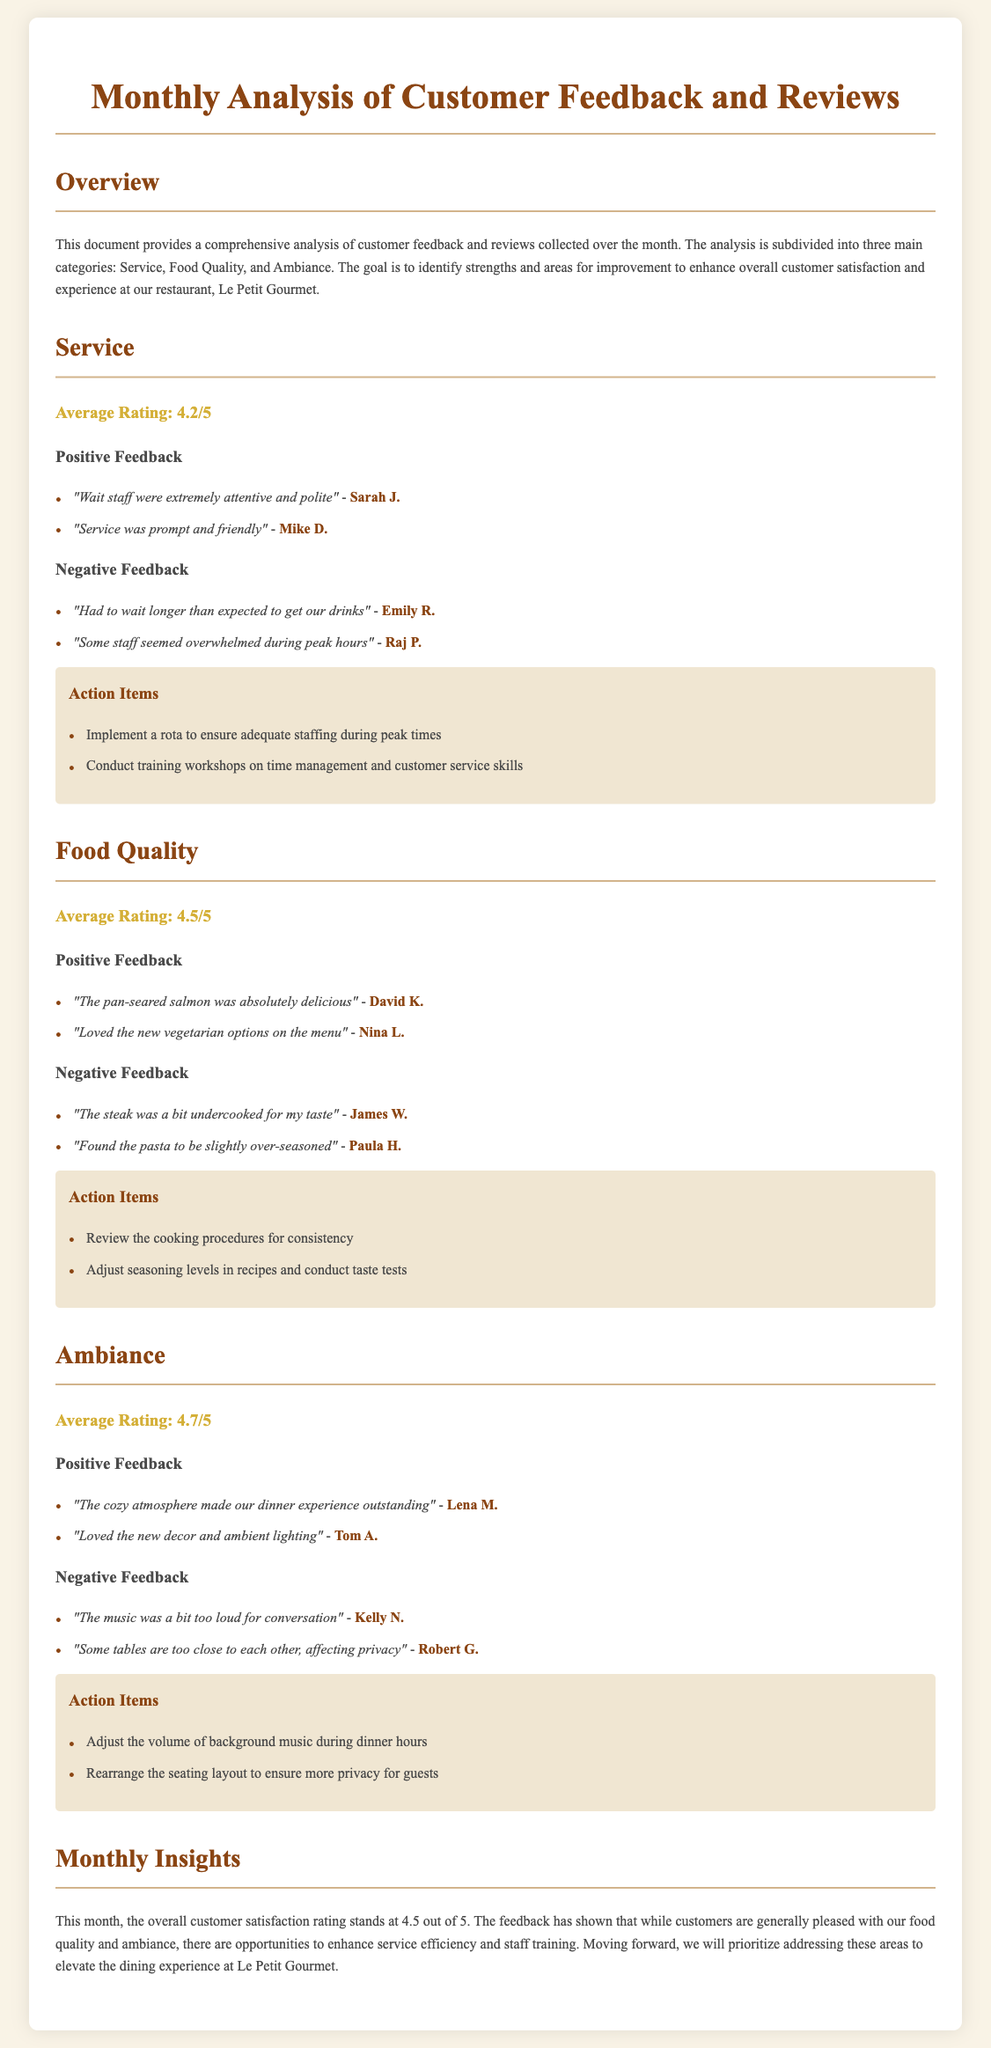What is the average rating for Service? The document states that the average rating for Service is 4.2 out of 5.
Answer: 4.2/5 What is the positive feedback about the food quality? The document includes a positive comment from David K. about the pan-seared salmon being delicious.
Answer: "The pan-seared salmon was absolutely delicious" How many action items are listed under Ambiance? The document contains two action items listed under the Ambiance section.
Answer: 2 What is the overall customer satisfaction rating for this month? The document mentions that the overall customer satisfaction rating is 4.5 out of 5.
Answer: 4.5/5 Which author commented on the loud music? The document lists Kelly N. as the author who commented on the music being too loud.
Answer: Kelly N What average rating did customers give Food Quality? The document specifies that the average rating for Food Quality is 4.5 out of 5.
Answer: 4.5/5 What is one action item to improve service? The document states that one action item is to conduct training workshops on time management and customer service skills.
Answer: Conduct training workshops on time management and customer service skills How many negative feedbacks were collected for the Service category? The document indicates that there are two negative feedbacks listed under the Service category.
Answer: 2 Which section received the highest average rating? The document shows that Ambiance received the highest average rating of 4.7 out of 5.
Answer: 4.7/5 